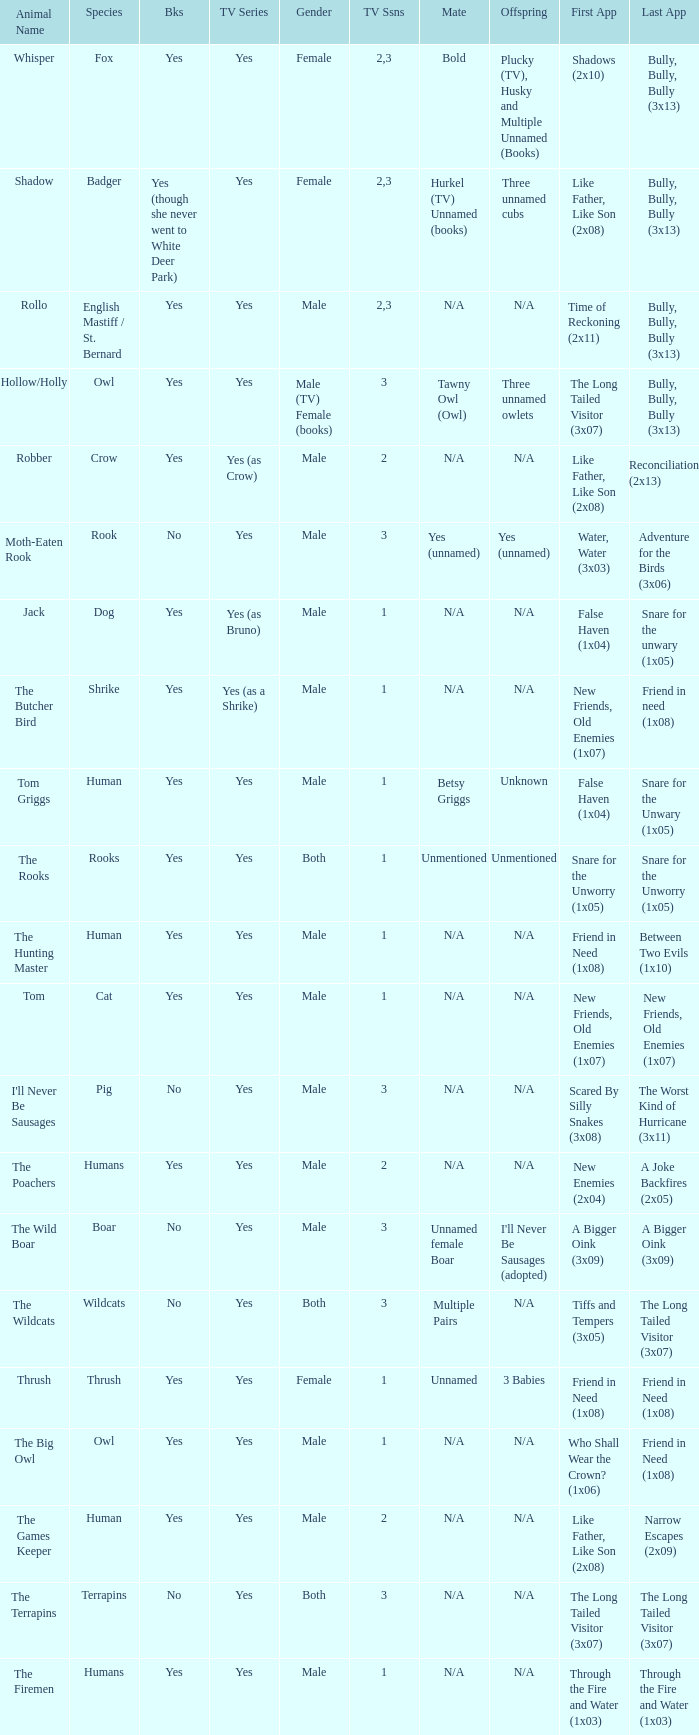What series includes a boar? Yes. 